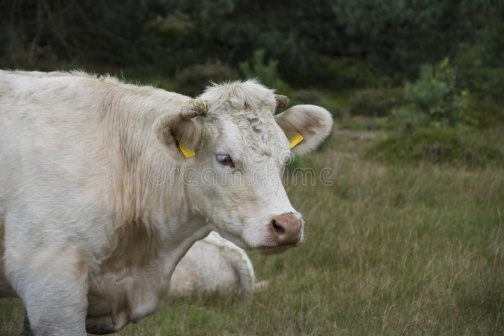Can you explain what the yellow tags on the cow's ears might indicate? The yellow tags in the cow's ears are likely identification tags, used by farmers for record-keeping and management purposes. Each tag has a unique number which helps in tracking the health, breeding, and grazing patterns of the animal. Such tags are essential in modern farming practices for ensuring the well-being of the livestock and efficient farm management. 